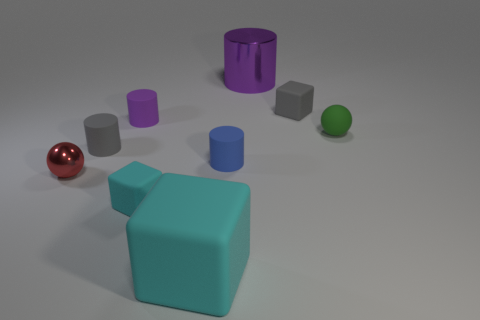There is a small rubber cube to the left of the gray object that is to the right of the purple shiny thing; is there a gray thing in front of it?
Your response must be concise. No. How many other objects are there of the same color as the shiny sphere?
Give a very brief answer. 0. What number of tiny rubber things are in front of the tiny purple thing and to the right of the purple shiny cylinder?
Offer a very short reply. 1. There is a tiny red thing; what shape is it?
Provide a succinct answer. Sphere. What number of other objects are the same material as the large cyan block?
Keep it short and to the point. 6. There is a metal thing that is behind the blue cylinder right of the cyan cube that is on the left side of the large rubber cube; what color is it?
Offer a very short reply. Purple. There is a cyan thing that is the same size as the metal cylinder; what material is it?
Offer a very short reply. Rubber. What number of things are tiny green things that are on the right side of the large metal object or cylinders?
Offer a terse response. 5. Are any small objects visible?
Ensure brevity in your answer.  Yes. There is a big block in front of the tiny gray cylinder; what is its material?
Your response must be concise. Rubber. 